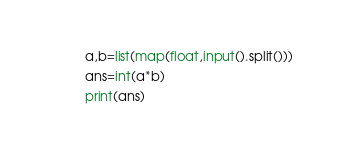Convert code to text. <code><loc_0><loc_0><loc_500><loc_500><_Python_>a,b=list(map(float,input().split()))
ans=int(a*b)
print(ans)</code> 